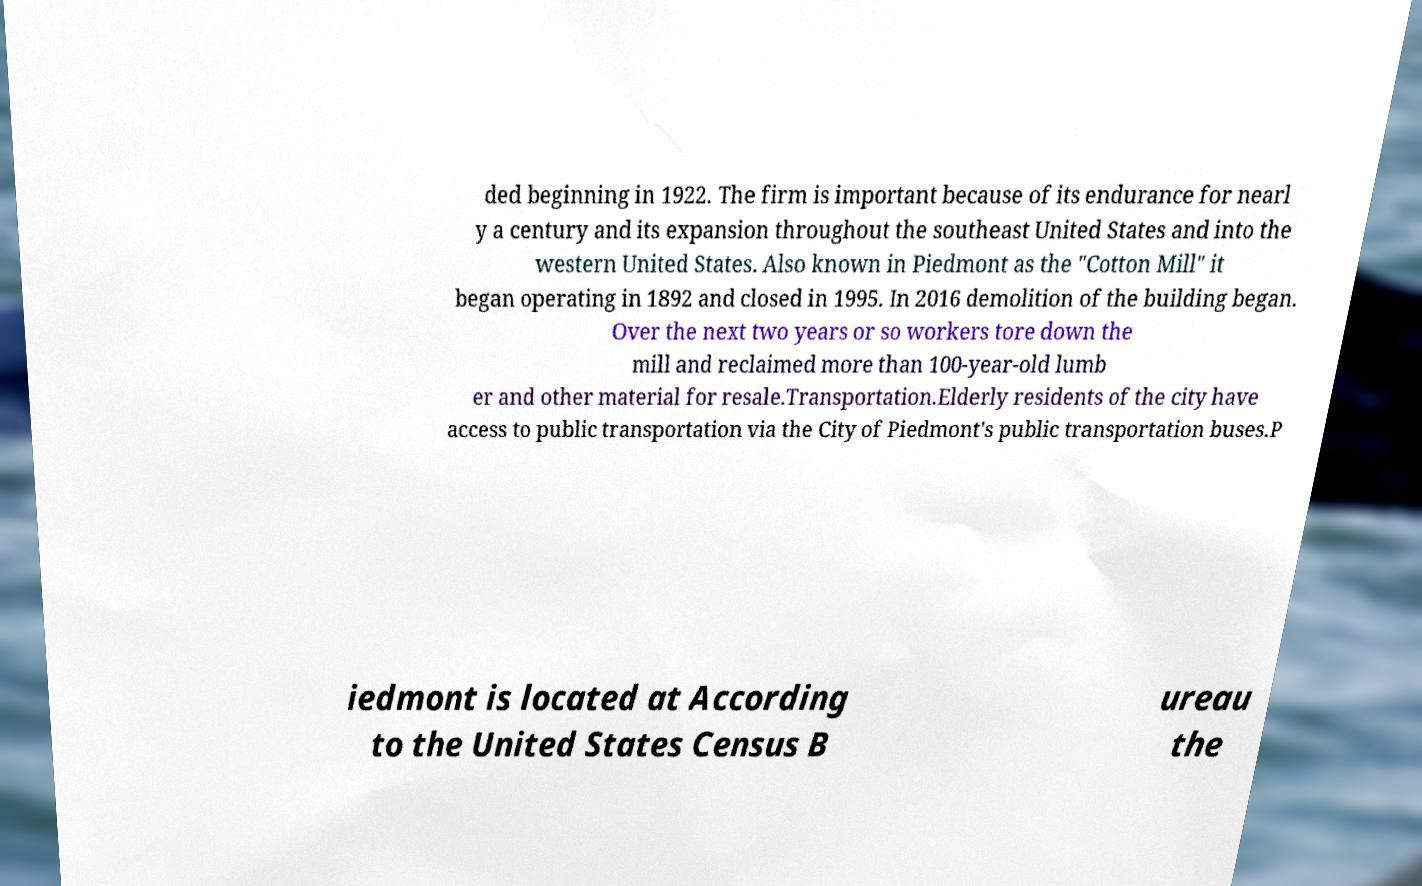Could you extract and type out the text from this image? ded beginning in 1922. The firm is important because of its endurance for nearl y a century and its expansion throughout the southeast United States and into the western United States. Also known in Piedmont as the "Cotton Mill" it began operating in 1892 and closed in 1995. In 2016 demolition of the building began. Over the next two years or so workers tore down the mill and reclaimed more than 100-year-old lumb er and other material for resale.Transportation.Elderly residents of the city have access to public transportation via the City of Piedmont's public transportation buses.P iedmont is located at According to the United States Census B ureau the 